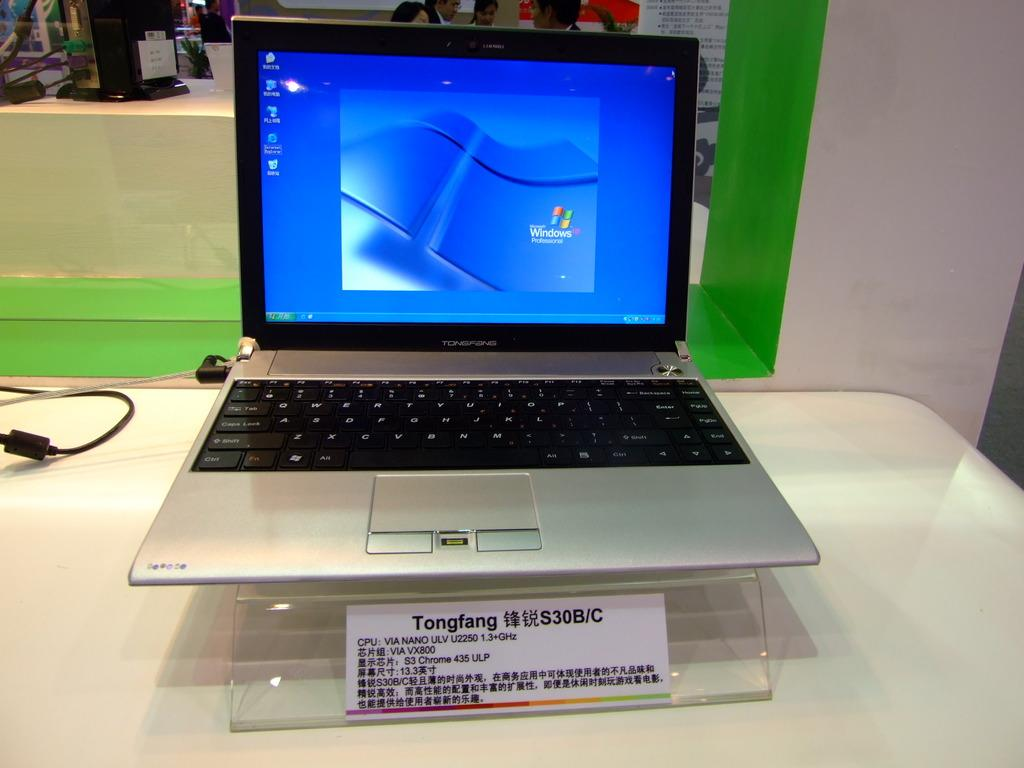Provide a one-sentence caption for the provided image. A tonfang laptop computer that has the screen open. 